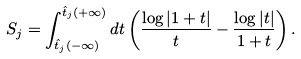Convert formula to latex. <formula><loc_0><loc_0><loc_500><loc_500>S _ { j } = \int _ { \hat { t } _ { j } ( - \infty ) } ^ { \hat { t } _ { j } ( + \infty ) } d t \left ( \frac { \log | 1 + t | } { t } - \frac { \log | t | } { 1 + t } \right ) .</formula> 